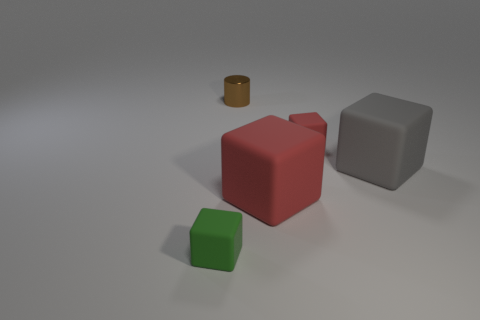Add 3 small rubber cylinders. How many objects exist? 8 Subtract all cubes. How many objects are left? 1 Add 4 small brown objects. How many small brown objects exist? 5 Subtract 0 yellow cubes. How many objects are left? 5 Subtract all small gray matte cubes. Subtract all big things. How many objects are left? 3 Add 4 tiny red things. How many tiny red things are left? 5 